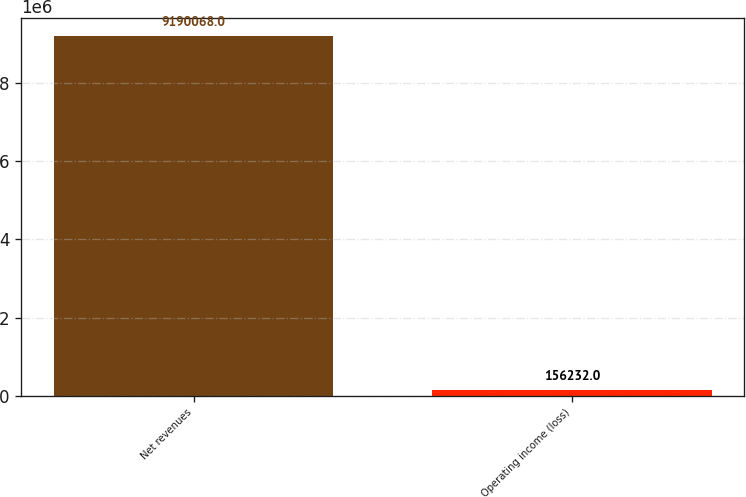Convert chart to OTSL. <chart><loc_0><loc_0><loc_500><loc_500><bar_chart><fcel>Net revenues<fcel>Operating income (loss)<nl><fcel>9.19007e+06<fcel>156232<nl></chart> 